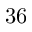Convert formula to latex. <formula><loc_0><loc_0><loc_500><loc_500>3 6</formula> 